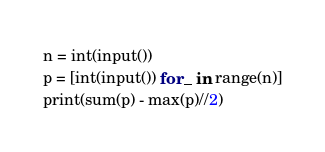<code> <loc_0><loc_0><loc_500><loc_500><_Python_>n = int(input())
p = [int(input()) for _ in range(n)]
print(sum(p) - max(p)//2)</code> 